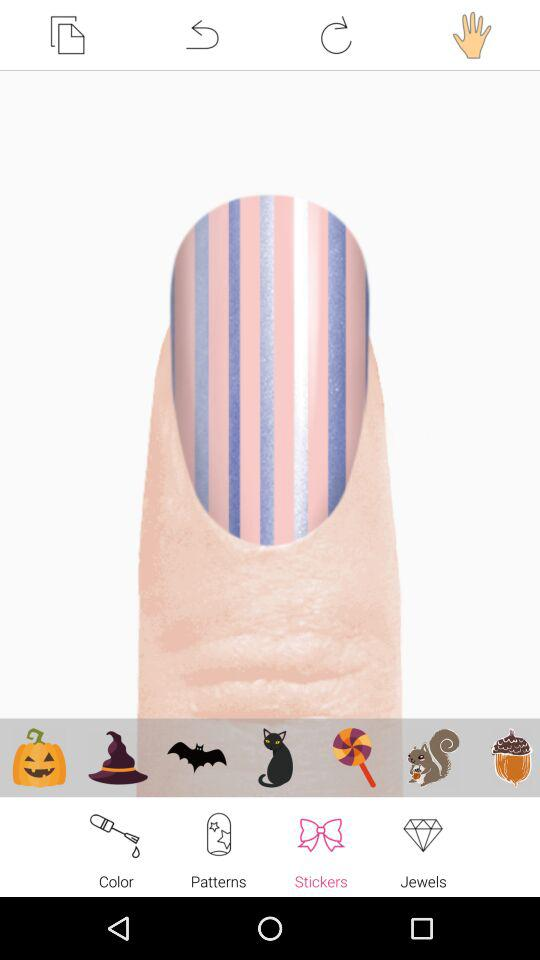Which tab is selected? The selected tab is "Stickers". 